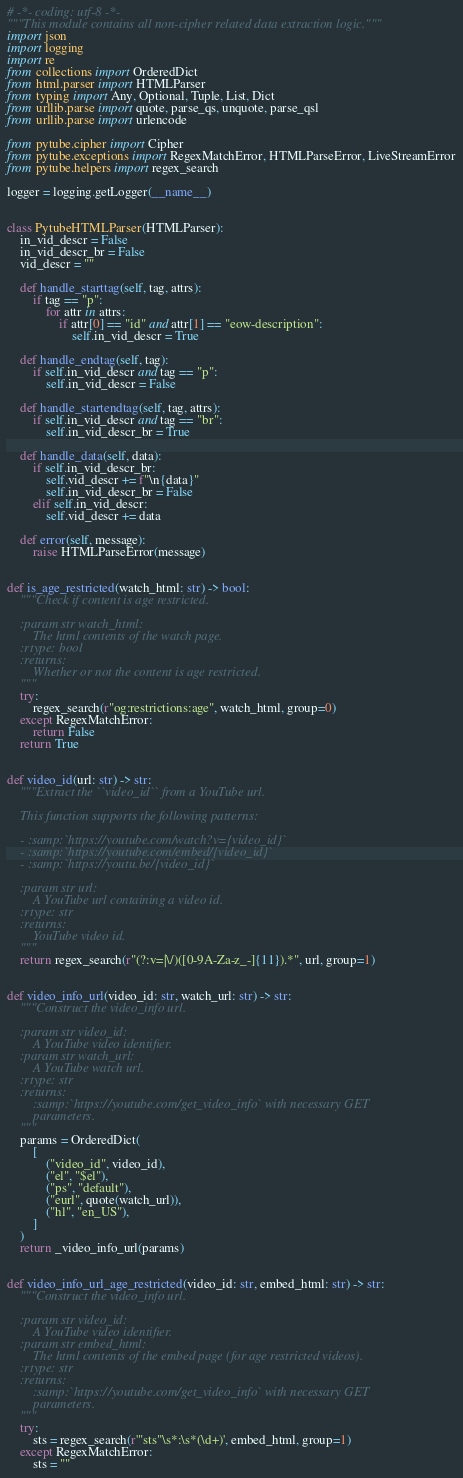Convert code to text. <code><loc_0><loc_0><loc_500><loc_500><_Python_># -*- coding: utf-8 -*-
"""This module contains all non-cipher related data extraction logic."""
import json
import logging
import re
from collections import OrderedDict
from html.parser import HTMLParser
from typing import Any, Optional, Tuple, List, Dict
from urllib.parse import quote, parse_qs, unquote, parse_qsl
from urllib.parse import urlencode

from pytube.cipher import Cipher
from pytube.exceptions import RegexMatchError, HTMLParseError, LiveStreamError
from pytube.helpers import regex_search

logger = logging.getLogger(__name__)


class PytubeHTMLParser(HTMLParser):
    in_vid_descr = False
    in_vid_descr_br = False
    vid_descr = ""

    def handle_starttag(self, tag, attrs):
        if tag == "p":
            for attr in attrs:
                if attr[0] == "id" and attr[1] == "eow-description":
                    self.in_vid_descr = True

    def handle_endtag(self, tag):
        if self.in_vid_descr and tag == "p":
            self.in_vid_descr = False

    def handle_startendtag(self, tag, attrs):
        if self.in_vid_descr and tag == "br":
            self.in_vid_descr_br = True

    def handle_data(self, data):
        if self.in_vid_descr_br:
            self.vid_descr += f"\n{data}"
            self.in_vid_descr_br = False
        elif self.in_vid_descr:
            self.vid_descr += data

    def error(self, message):
        raise HTMLParseError(message)


def is_age_restricted(watch_html: str) -> bool:
    """Check if content is age restricted.

    :param str watch_html:
        The html contents of the watch page.
    :rtype: bool
    :returns:
        Whether or not the content is age restricted.
    """
    try:
        regex_search(r"og:restrictions:age", watch_html, group=0)
    except RegexMatchError:
        return False
    return True


def video_id(url: str) -> str:
    """Extract the ``video_id`` from a YouTube url.

    This function supports the following patterns:

    - :samp:`https://youtube.com/watch?v={video_id}`
    - :samp:`https://youtube.com/embed/{video_id}`
    - :samp:`https://youtu.be/{video_id}`

    :param str url:
        A YouTube url containing a video id.
    :rtype: str
    :returns:
        YouTube video id.
    """
    return regex_search(r"(?:v=|\/)([0-9A-Za-z_-]{11}).*", url, group=1)


def video_info_url(video_id: str, watch_url: str) -> str:
    """Construct the video_info url.

    :param str video_id:
        A YouTube video identifier.
    :param str watch_url:
        A YouTube watch url.
    :rtype: str
    :returns:
        :samp:`https://youtube.com/get_video_info` with necessary GET
        parameters.
    """
    params = OrderedDict(
        [
            ("video_id", video_id),
            ("el", "$el"),
            ("ps", "default"),
            ("eurl", quote(watch_url)),
            ("hl", "en_US"),
        ]
    )
    return _video_info_url(params)


def video_info_url_age_restricted(video_id: str, embed_html: str) -> str:
    """Construct the video_info url.

    :param str video_id:
        A YouTube video identifier.
    :param str embed_html:
        The html contents of the embed page (for age restricted videos).
    :rtype: str
    :returns:
        :samp:`https://youtube.com/get_video_info` with necessary GET
        parameters.
    """
    try:
        sts = regex_search(r'"sts"\s*:\s*(\d+)', embed_html, group=1)
    except RegexMatchError:
        sts = ""</code> 